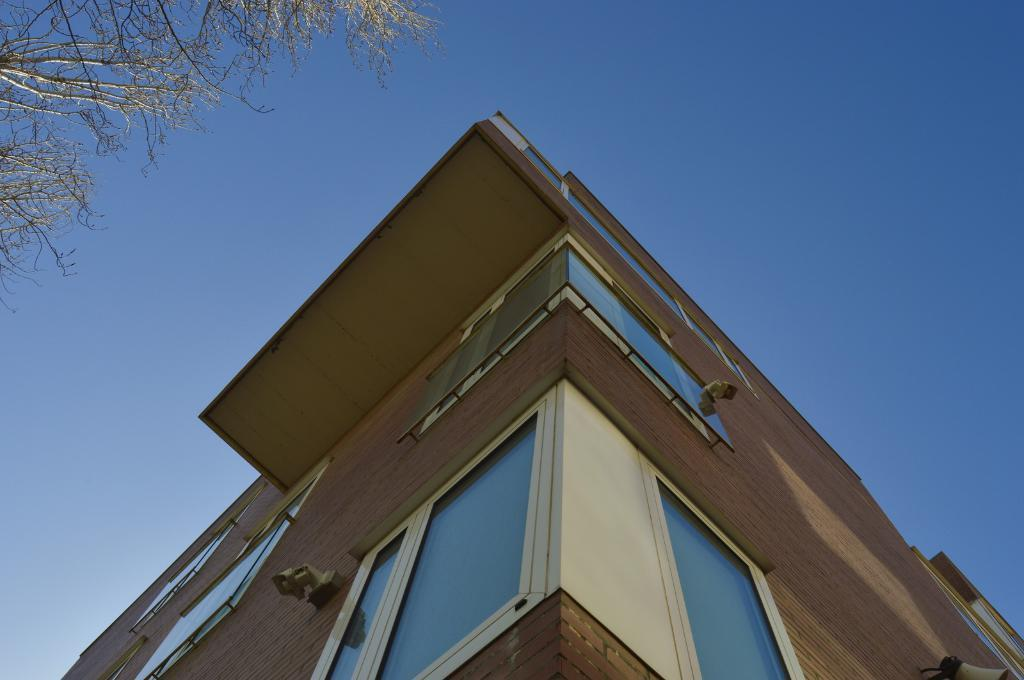What type of structure is present in the image? There is a building in the image. What can be seen in the background of the image? There is a tree and the sky visible in the background of the image. What type of canvas is stretched across the bridge in the image? There is no bridge or canvas present in the image; it only features a building and a tree in the background. 